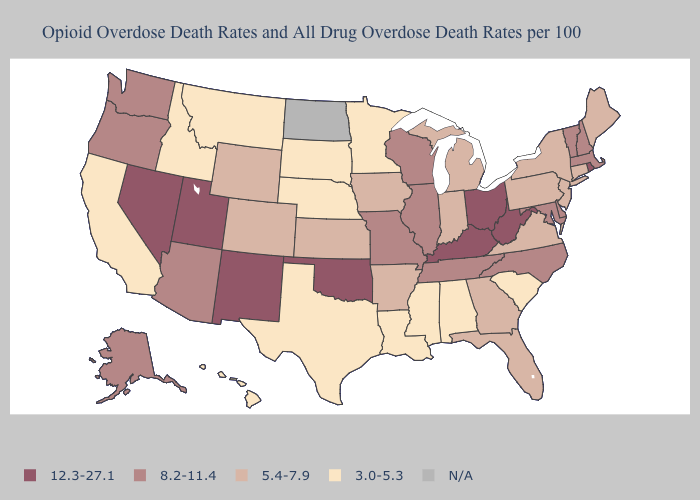Is the legend a continuous bar?
Quick response, please. No. Name the states that have a value in the range 5.4-7.9?
Concise answer only. Arkansas, Colorado, Connecticut, Florida, Georgia, Indiana, Iowa, Kansas, Maine, Michigan, New Jersey, New York, Pennsylvania, Virginia, Wyoming. Name the states that have a value in the range 3.0-5.3?
Quick response, please. Alabama, California, Hawaii, Idaho, Louisiana, Minnesota, Mississippi, Montana, Nebraska, South Carolina, South Dakota, Texas. Name the states that have a value in the range 5.4-7.9?
Answer briefly. Arkansas, Colorado, Connecticut, Florida, Georgia, Indiana, Iowa, Kansas, Maine, Michigan, New Jersey, New York, Pennsylvania, Virginia, Wyoming. Name the states that have a value in the range 12.3-27.1?
Write a very short answer. Kentucky, Nevada, New Mexico, Ohio, Oklahoma, Rhode Island, Utah, West Virginia. Does Oklahoma have the highest value in the USA?
Answer briefly. Yes. Which states hav the highest value in the Northeast?
Quick response, please. Rhode Island. Name the states that have a value in the range 5.4-7.9?
Give a very brief answer. Arkansas, Colorado, Connecticut, Florida, Georgia, Indiana, Iowa, Kansas, Maine, Michigan, New Jersey, New York, Pennsylvania, Virginia, Wyoming. Does the first symbol in the legend represent the smallest category?
Write a very short answer. No. What is the value of Delaware?
Be succinct. 8.2-11.4. Does Utah have the lowest value in the West?
Quick response, please. No. What is the value of Maine?
Give a very brief answer. 5.4-7.9. Does Arizona have the lowest value in the USA?
Concise answer only. No. What is the value of South Dakota?
Give a very brief answer. 3.0-5.3. 